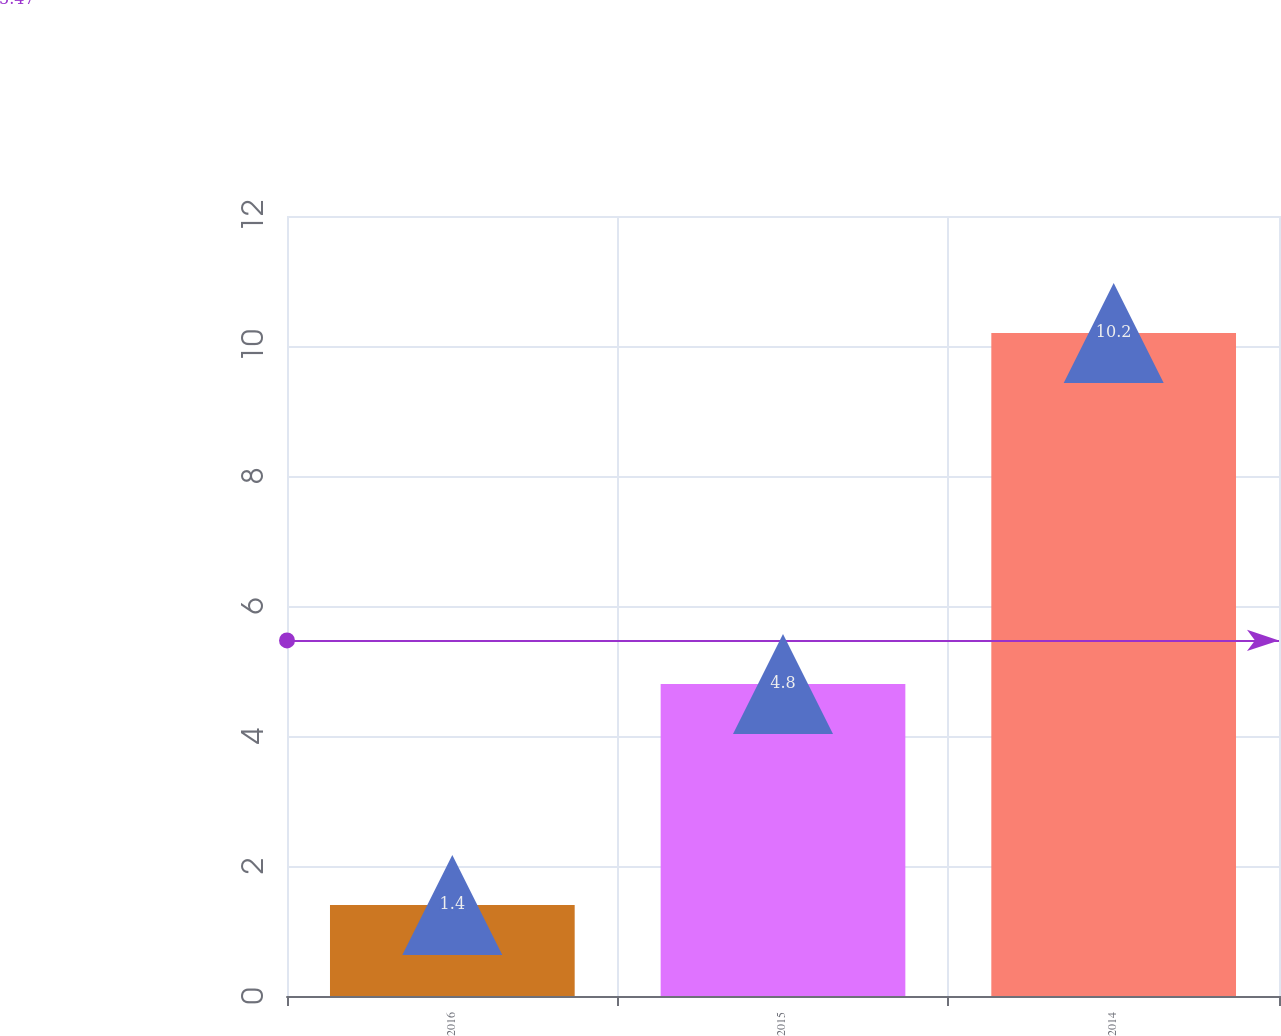Convert chart to OTSL. <chart><loc_0><loc_0><loc_500><loc_500><bar_chart><fcel>2016<fcel>2015<fcel>2014<nl><fcel>1.4<fcel>4.8<fcel>10.2<nl></chart> 